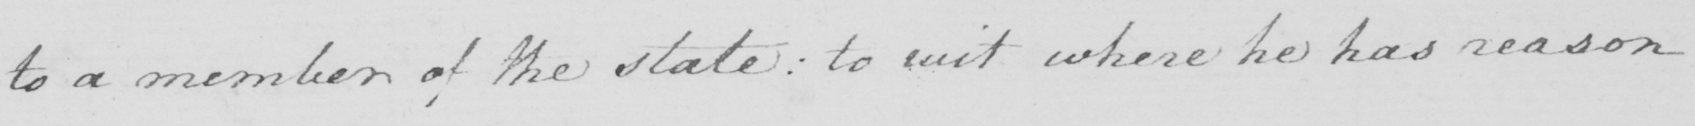What is written in this line of handwriting? to a member of the state :  to wit where he has reason 